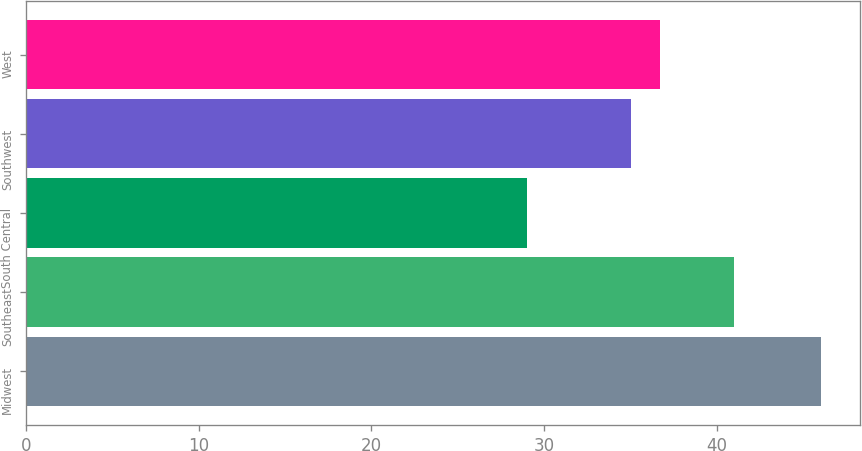<chart> <loc_0><loc_0><loc_500><loc_500><bar_chart><fcel>Midwest<fcel>Southeast<fcel>South Central<fcel>Southwest<fcel>West<nl><fcel>46<fcel>41<fcel>29<fcel>35<fcel>36.7<nl></chart> 